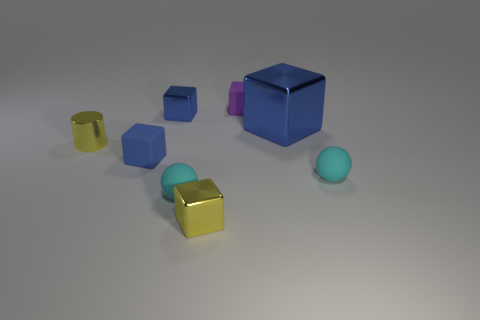Subtract all small blocks. How many blocks are left? 1 Add 1 large cyan cylinders. How many objects exist? 9 Subtract all purple cubes. How many cubes are left? 4 Subtract all cylinders. How many objects are left? 7 Subtract 1 cylinders. How many cylinders are left? 0 Subtract all blue cylinders. How many purple cubes are left? 1 Subtract all small blue metal things. Subtract all cyan things. How many objects are left? 5 Add 8 small matte blocks. How many small matte blocks are left? 10 Add 6 small red rubber blocks. How many small red rubber blocks exist? 6 Subtract 0 gray spheres. How many objects are left? 8 